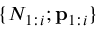<formula> <loc_0><loc_0><loc_500><loc_500>\{ N _ { 1 \colon i } ; p _ { 1 \colon i } \}</formula> 